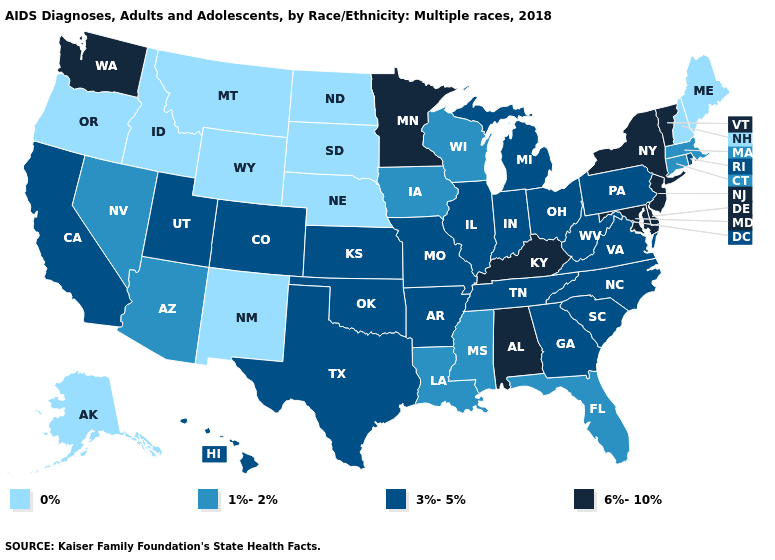How many symbols are there in the legend?
Short answer required. 4. Which states have the highest value in the USA?
Short answer required. Alabama, Delaware, Kentucky, Maryland, Minnesota, New Jersey, New York, Vermont, Washington. Name the states that have a value in the range 6%-10%?
Short answer required. Alabama, Delaware, Kentucky, Maryland, Minnesota, New Jersey, New York, Vermont, Washington. Name the states that have a value in the range 0%?
Short answer required. Alaska, Idaho, Maine, Montana, Nebraska, New Hampshire, New Mexico, North Dakota, Oregon, South Dakota, Wyoming. What is the value of Washington?
Be succinct. 6%-10%. Among the states that border Delaware , which have the highest value?
Keep it brief. Maryland, New Jersey. Name the states that have a value in the range 3%-5%?
Answer briefly. Arkansas, California, Colorado, Georgia, Hawaii, Illinois, Indiana, Kansas, Michigan, Missouri, North Carolina, Ohio, Oklahoma, Pennsylvania, Rhode Island, South Carolina, Tennessee, Texas, Utah, Virginia, West Virginia. Does Utah have a higher value than North Carolina?
Short answer required. No. What is the value of New Jersey?
Quick response, please. 6%-10%. What is the lowest value in the Northeast?
Answer briefly. 0%. Is the legend a continuous bar?
Give a very brief answer. No. What is the highest value in states that border Minnesota?
Be succinct. 1%-2%. Among the states that border New Hampshire , which have the lowest value?
Give a very brief answer. Maine. What is the lowest value in the Northeast?
Write a very short answer. 0%. Name the states that have a value in the range 1%-2%?
Answer briefly. Arizona, Connecticut, Florida, Iowa, Louisiana, Massachusetts, Mississippi, Nevada, Wisconsin. 